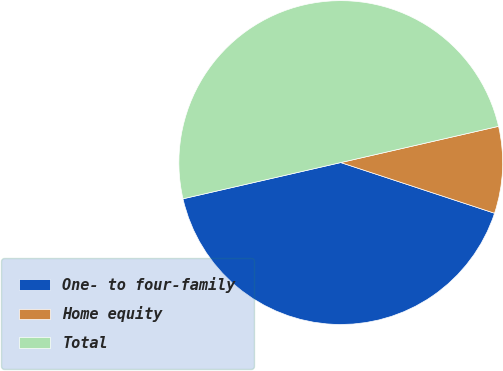Convert chart. <chart><loc_0><loc_0><loc_500><loc_500><pie_chart><fcel>One- to four-family<fcel>Home equity<fcel>Total<nl><fcel>41.34%<fcel>8.66%<fcel>50.0%<nl></chart> 